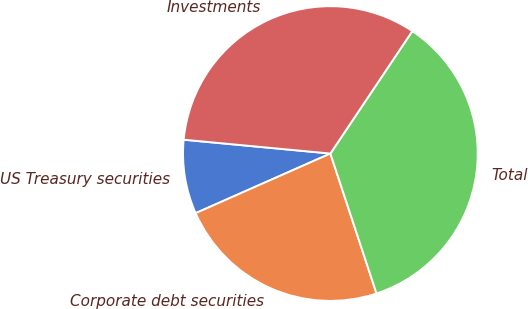Convert chart. <chart><loc_0><loc_0><loc_500><loc_500><pie_chart><fcel>US Treasury securities<fcel>Corporate debt securities<fcel>Total<fcel>Investments<nl><fcel>8.13%<fcel>23.44%<fcel>35.55%<fcel>32.89%<nl></chart> 